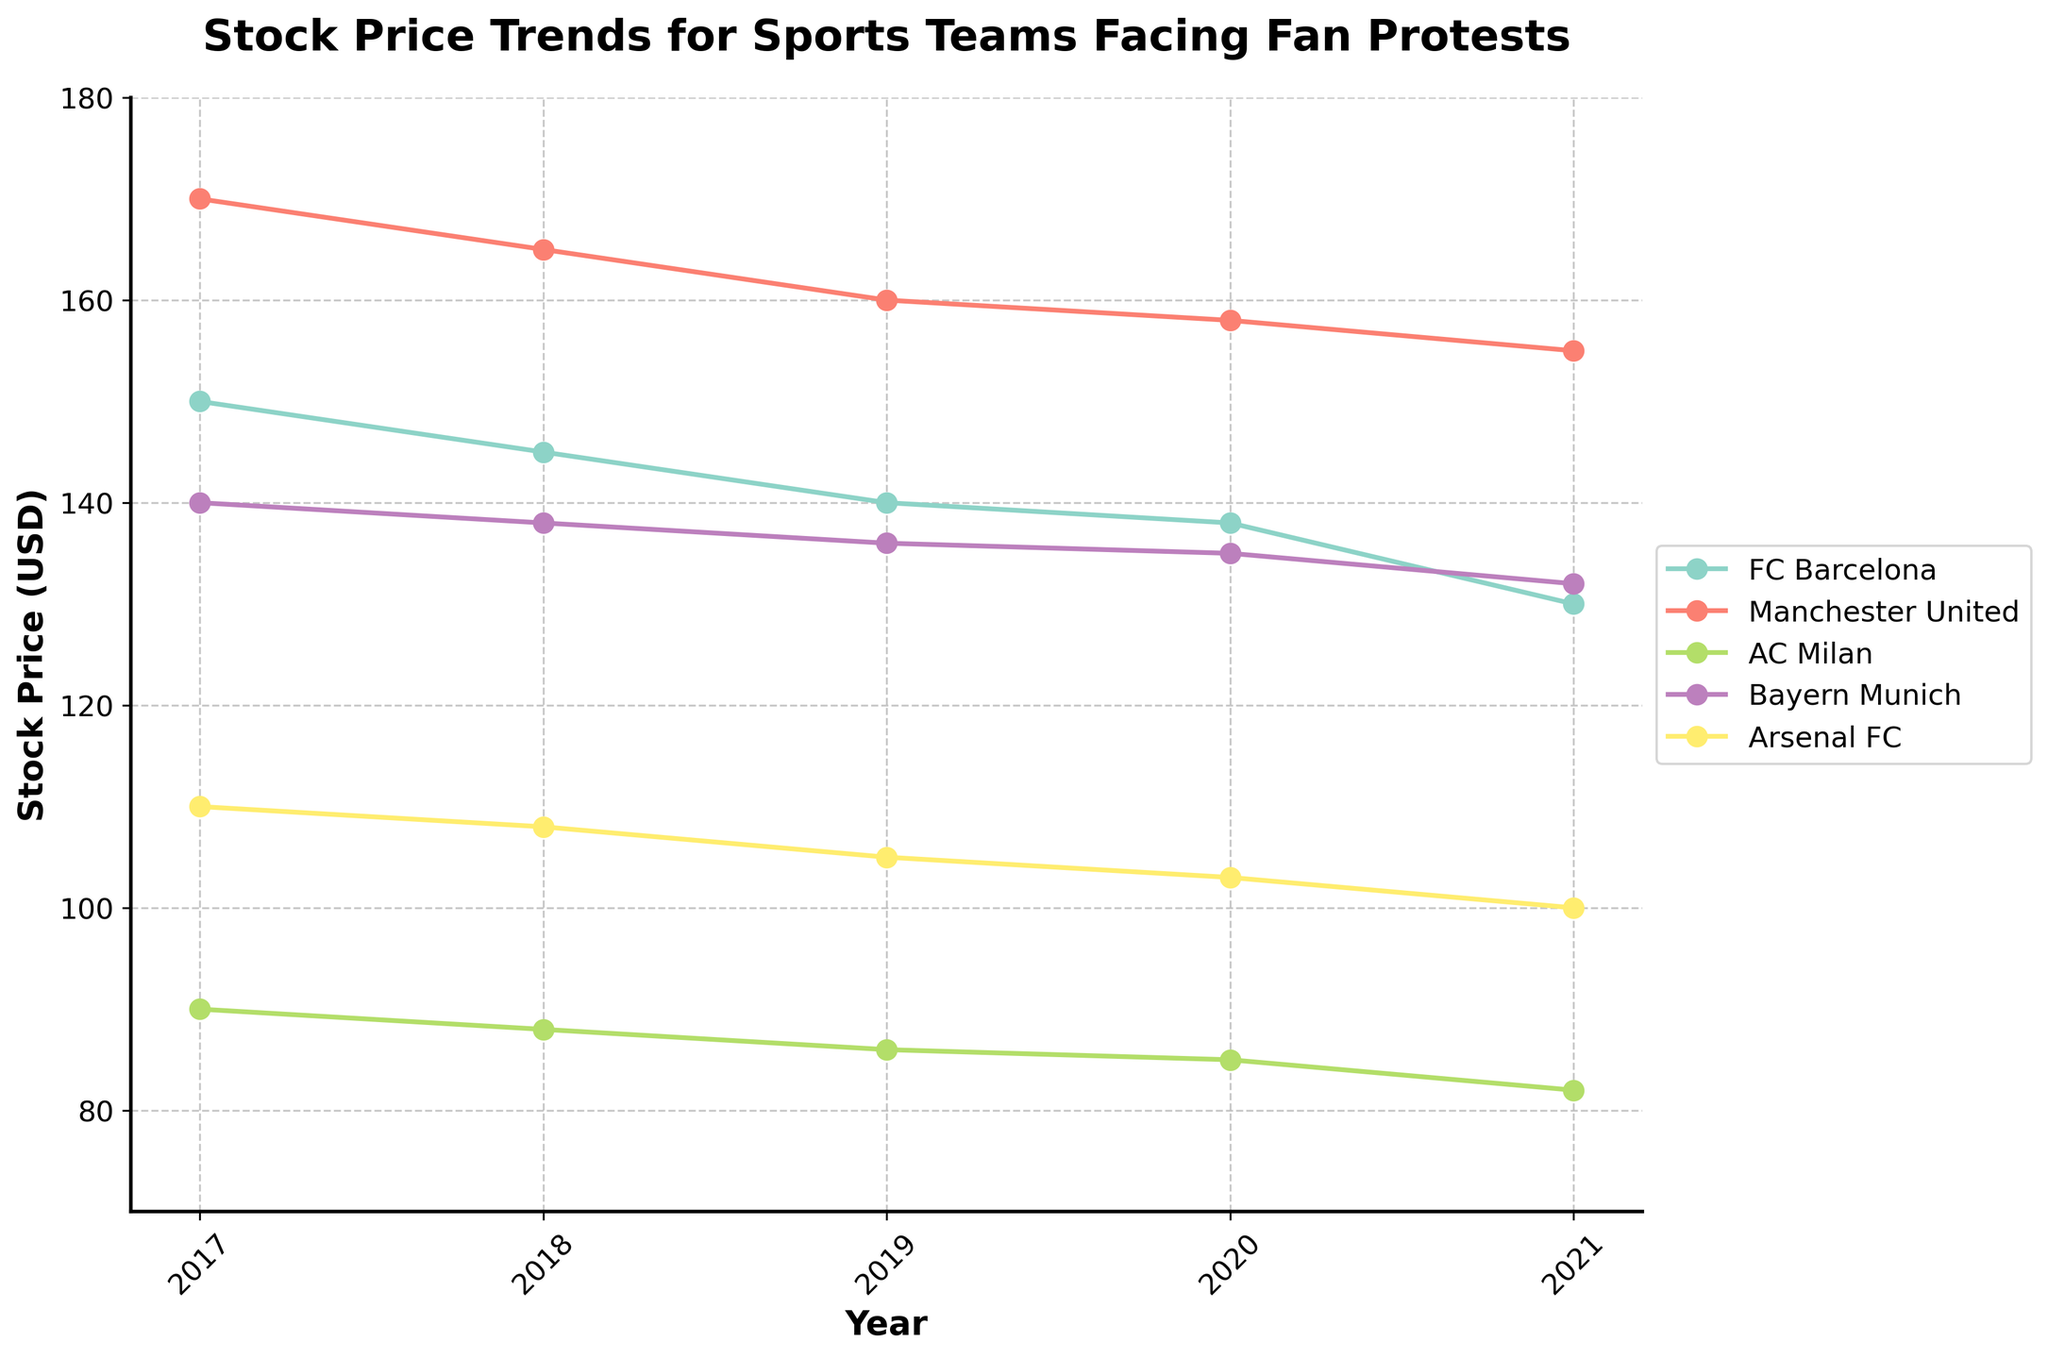What is the title of the plot? The plot title is located at the top center of the figure and it reads 'Stock Price Trends for Sports Teams Facing Fan Protests'.
Answer: Stock Price Trends for Sports Teams Facing Fan Protests Which team had the highest stock price in 2021? To find the team with the highest stock price in 2021, look at the end points of each line on the right side of the plot. The highest point among these represents the highest stock price. Manchester United had the highest stock price.
Answer: Manchester United What is the trend in FC Barcelona's stock price from 2017 to 2021? Find the line corresponding to FC Barcelona and observe the change from 2017 to 2021. The line consistently declines from 150 USD to 130 USD.
Answer: Declining How much did Bayern Munich's stock price decrease from 2019 to 2021? Locate the points for Bayern Munich in 2019 and 2021, then subtract the 2021 value from the 2019 value. The stock price decreased from 136 USD to 132 USD, so the difference is 4 USD.
Answer: 4 USD Which two teams had nearly identical stock prices in 2021? Examine the end points of the lines for 2021 and find two points that are close to each other. FC Barcelona and Bayern Munich had nearly identical stock prices, both around 132 USD.
Answer: FC Barcelona and Bayern Munich Which team experienced the most significant drop in stock price over the years? Look at all the lines from 2017 to 2021 and determine which line has the steepest decline. FC Barcelona shows the steepest decline, from 150 USD to 130 USD, which is a 20 USD drop.
Answer: FC Barcelona What was Arsenal FC's stock price in 2020? Find the line for Arsenal FC and locate the point corresponding to the year 2020 on the x-axis. The stock price for Arsenal FC in 2020 is at 103 USD.
Answer: 103 USD Between 2018 and 2021, which team had the least change in stock price? Compare the changes between 2018 to 2021 for each team by observing the slopes of the lines. A smaller slope indicates lesser change. Bayern Munich's stock price changed the least, from 138 USD to 132 USD, a 6 USD change.
Answer: Bayern Munich As of 2019, how many teams had a stock price above 135 USD? Identify the points for all teams in 2019 and count how many points are above the 135 USD mark on the y-axis. There are three teams: FC Barcelona, Manchester United, and Bayern Munich.
Answer: 3 teams 